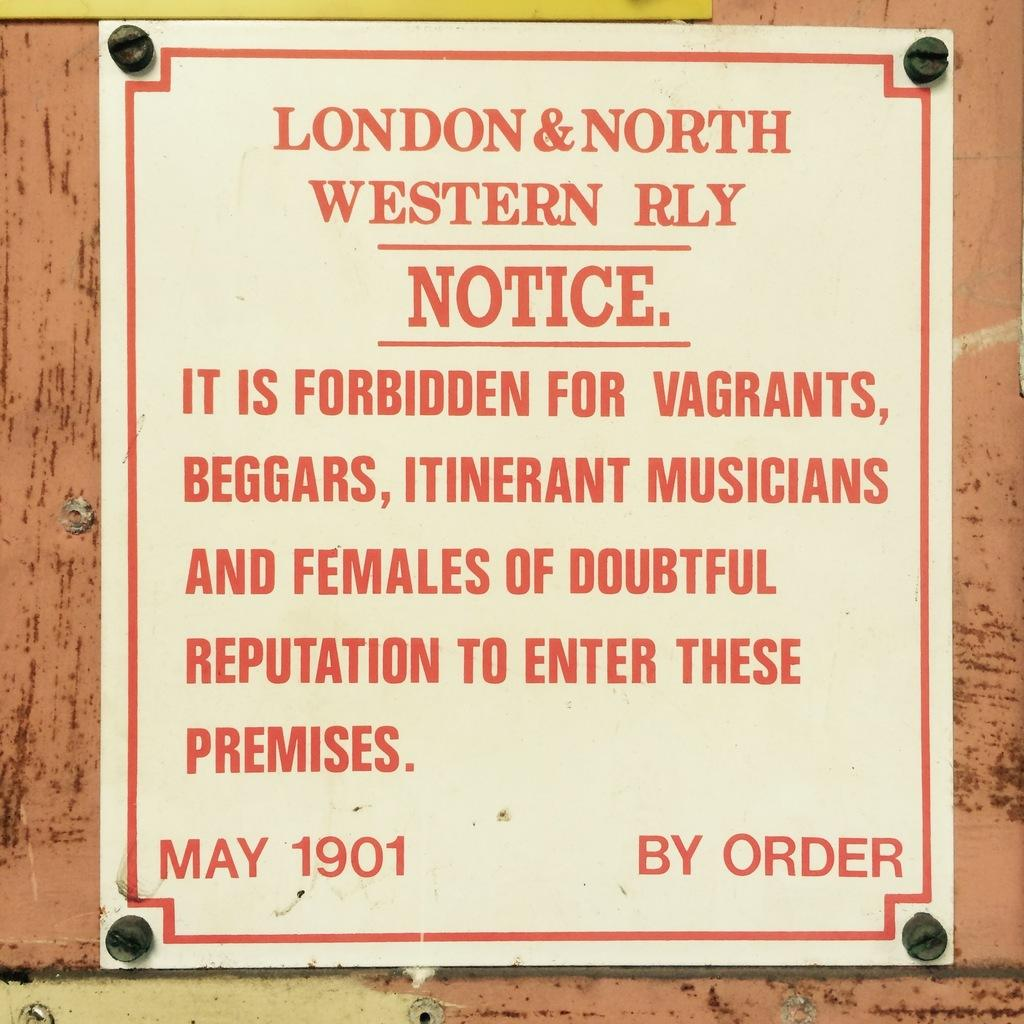<image>
Provide a brief description of the given image. A notice by London & North forbidding entrance to undesirables. 